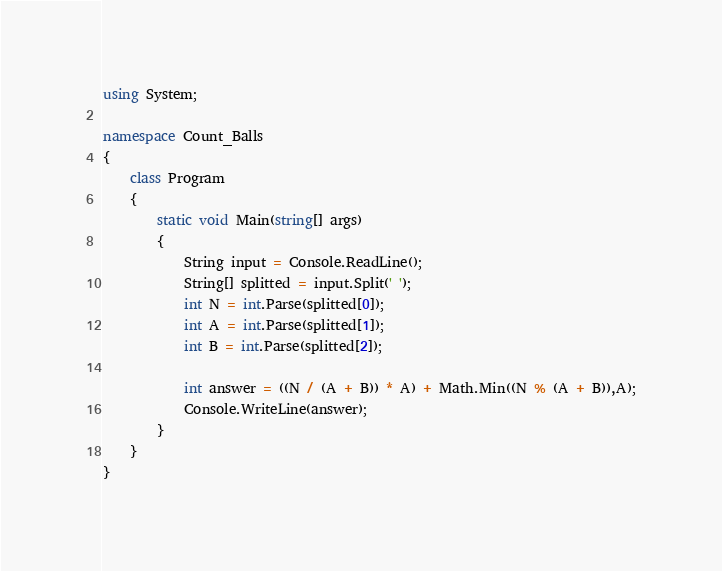Convert code to text. <code><loc_0><loc_0><loc_500><loc_500><_C#_>using System;

namespace Count_Balls
{
    class Program
    {
        static void Main(string[] args)
        {
            String input = Console.ReadLine();
            String[] splitted = input.Split(' ');
            int N = int.Parse(splitted[0]);
            int A = int.Parse(splitted[1]);
            int B = int.Parse(splitted[2]);

            int answer = ((N / (A + B)) * A) + Math.Min((N % (A + B)),A);
            Console.WriteLine(answer);
        }
    }
}
</code> 